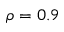Convert formula to latex. <formula><loc_0><loc_0><loc_500><loc_500>\rho = 0 . 9</formula> 